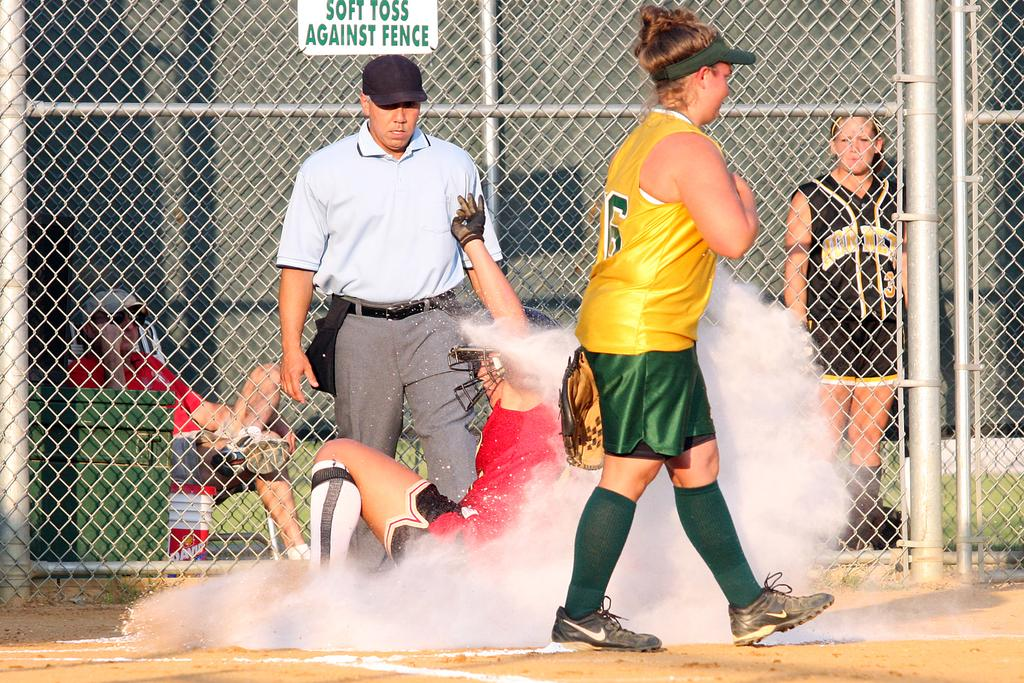<image>
Render a clear and concise summary of the photo. A softball player is sliding into home base with a sign behind saying soft toss against fence 